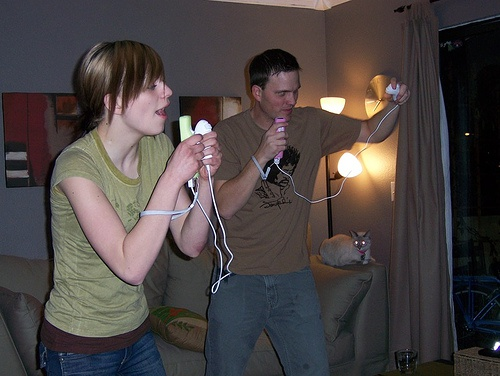Describe the objects in this image and their specific colors. I can see people in black, darkgray, and gray tones, people in black and gray tones, couch in black and purple tones, bicycle in black, navy, darkblue, and gray tones, and cat in black, gray, and brown tones in this image. 